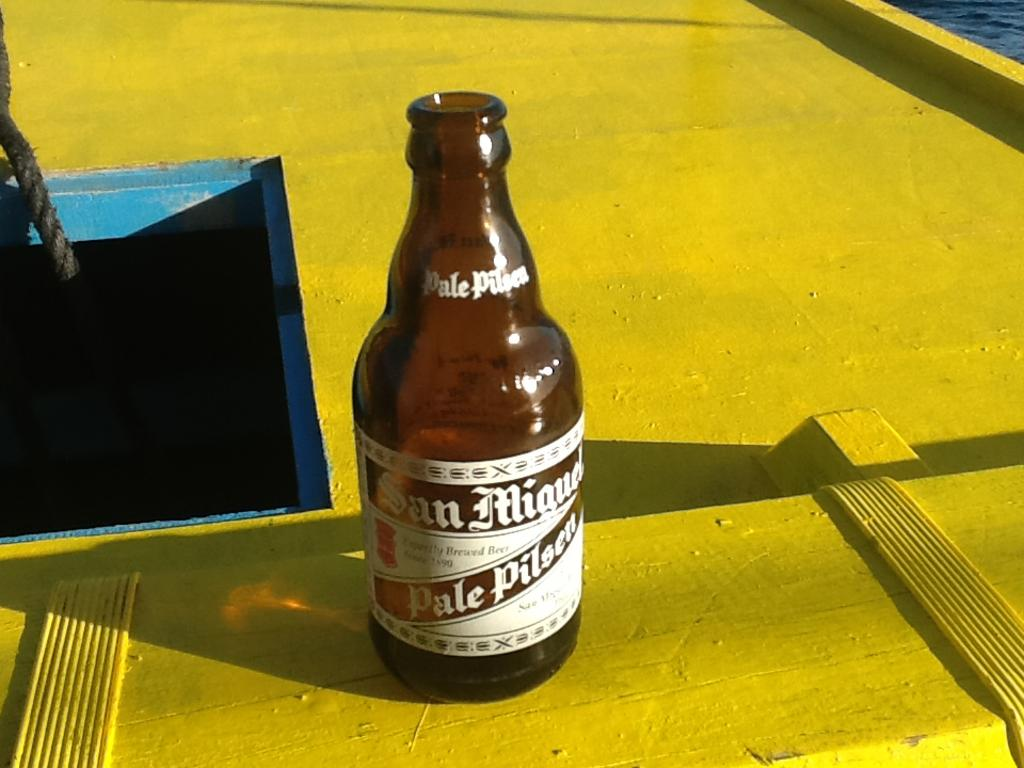Provide a one-sentence caption for the provided image. A bottle of Pale Pilsen has a white label. 